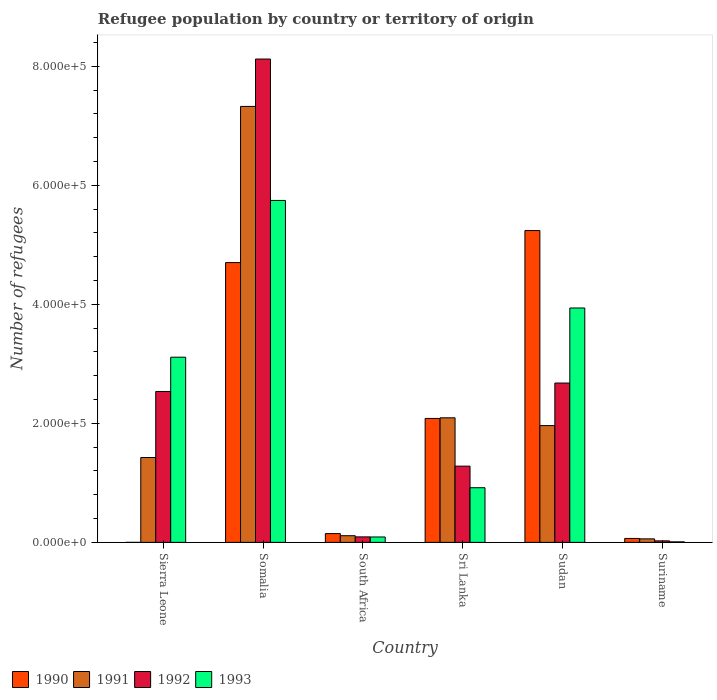How many different coloured bars are there?
Offer a very short reply. 4. How many bars are there on the 1st tick from the left?
Offer a very short reply. 4. How many bars are there on the 5th tick from the right?
Your answer should be compact. 4. What is the label of the 3rd group of bars from the left?
Make the answer very short. South Africa. In how many cases, is the number of bars for a given country not equal to the number of legend labels?
Give a very brief answer. 0. What is the number of refugees in 1990 in South Africa?
Your response must be concise. 1.48e+04. Across all countries, what is the maximum number of refugees in 1992?
Offer a very short reply. 8.12e+05. Across all countries, what is the minimum number of refugees in 1991?
Offer a terse response. 5921. In which country was the number of refugees in 1991 maximum?
Make the answer very short. Somalia. In which country was the number of refugees in 1993 minimum?
Ensure brevity in your answer.  Suriname. What is the total number of refugees in 1992 in the graph?
Your answer should be very brief. 1.47e+06. What is the difference between the number of refugees in 1990 in South Africa and that in Suriname?
Give a very brief answer. 8163. What is the difference between the number of refugees in 1990 in South Africa and the number of refugees in 1991 in Sri Lanka?
Your answer should be compact. -1.95e+05. What is the average number of refugees in 1992 per country?
Offer a terse response. 2.46e+05. What is the difference between the number of refugees of/in 1993 and number of refugees of/in 1992 in South Africa?
Offer a terse response. -147. In how many countries, is the number of refugees in 1991 greater than 400000?
Offer a very short reply. 1. What is the ratio of the number of refugees in 1993 in Sri Lanka to that in Suriname?
Provide a short and direct response. 102.85. What is the difference between the highest and the second highest number of refugees in 1993?
Your answer should be very brief. -2.63e+05. What is the difference between the highest and the lowest number of refugees in 1991?
Offer a terse response. 7.27e+05. Is the sum of the number of refugees in 1993 in Sierra Leone and Sri Lanka greater than the maximum number of refugees in 1990 across all countries?
Offer a very short reply. No. Is it the case that in every country, the sum of the number of refugees in 1991 and number of refugees in 1990 is greater than the sum of number of refugees in 1993 and number of refugees in 1992?
Ensure brevity in your answer.  No. What does the 4th bar from the right in Somalia represents?
Offer a terse response. 1990. Is it the case that in every country, the sum of the number of refugees in 1992 and number of refugees in 1993 is greater than the number of refugees in 1990?
Give a very brief answer. No. How many countries are there in the graph?
Your answer should be compact. 6. What is the difference between two consecutive major ticks on the Y-axis?
Provide a succinct answer. 2.00e+05. Does the graph contain any zero values?
Your answer should be very brief. No. How many legend labels are there?
Make the answer very short. 4. How are the legend labels stacked?
Offer a very short reply. Horizontal. What is the title of the graph?
Your answer should be compact. Refugee population by country or territory of origin. Does "1994" appear as one of the legend labels in the graph?
Make the answer very short. No. What is the label or title of the Y-axis?
Your answer should be very brief. Number of refugees. What is the Number of refugees in 1990 in Sierra Leone?
Offer a terse response. 9. What is the Number of refugees in 1991 in Sierra Leone?
Provide a succinct answer. 1.43e+05. What is the Number of refugees in 1992 in Sierra Leone?
Your answer should be compact. 2.54e+05. What is the Number of refugees in 1993 in Sierra Leone?
Your answer should be very brief. 3.11e+05. What is the Number of refugees in 1990 in Somalia?
Provide a succinct answer. 4.70e+05. What is the Number of refugees of 1991 in Somalia?
Ensure brevity in your answer.  7.33e+05. What is the Number of refugees of 1992 in Somalia?
Provide a succinct answer. 8.12e+05. What is the Number of refugees of 1993 in Somalia?
Your answer should be very brief. 5.75e+05. What is the Number of refugees of 1990 in South Africa?
Your answer should be compact. 1.48e+04. What is the Number of refugees of 1991 in South Africa?
Provide a short and direct response. 1.12e+04. What is the Number of refugees in 1992 in South Africa?
Keep it short and to the point. 9241. What is the Number of refugees of 1993 in South Africa?
Make the answer very short. 9094. What is the Number of refugees of 1990 in Sri Lanka?
Offer a very short reply. 2.08e+05. What is the Number of refugees in 1991 in Sri Lanka?
Your answer should be compact. 2.09e+05. What is the Number of refugees of 1992 in Sri Lanka?
Provide a short and direct response. 1.28e+05. What is the Number of refugees of 1993 in Sri Lanka?
Ensure brevity in your answer.  9.18e+04. What is the Number of refugees of 1990 in Sudan?
Ensure brevity in your answer.  5.24e+05. What is the Number of refugees of 1991 in Sudan?
Provide a succinct answer. 1.96e+05. What is the Number of refugees in 1992 in Sudan?
Ensure brevity in your answer.  2.68e+05. What is the Number of refugees of 1993 in Sudan?
Offer a very short reply. 3.94e+05. What is the Number of refugees of 1990 in Suriname?
Ensure brevity in your answer.  6620. What is the Number of refugees in 1991 in Suriname?
Offer a very short reply. 5921. What is the Number of refugees of 1992 in Suriname?
Make the answer very short. 2545. What is the Number of refugees in 1993 in Suriname?
Your answer should be very brief. 893. Across all countries, what is the maximum Number of refugees in 1990?
Give a very brief answer. 5.24e+05. Across all countries, what is the maximum Number of refugees in 1991?
Keep it short and to the point. 7.33e+05. Across all countries, what is the maximum Number of refugees in 1992?
Ensure brevity in your answer.  8.12e+05. Across all countries, what is the maximum Number of refugees in 1993?
Ensure brevity in your answer.  5.75e+05. Across all countries, what is the minimum Number of refugees in 1991?
Your response must be concise. 5921. Across all countries, what is the minimum Number of refugees of 1992?
Offer a very short reply. 2545. Across all countries, what is the minimum Number of refugees of 1993?
Make the answer very short. 893. What is the total Number of refugees in 1990 in the graph?
Give a very brief answer. 1.22e+06. What is the total Number of refugees of 1991 in the graph?
Offer a very short reply. 1.30e+06. What is the total Number of refugees of 1992 in the graph?
Provide a short and direct response. 1.47e+06. What is the total Number of refugees of 1993 in the graph?
Your response must be concise. 1.38e+06. What is the difference between the Number of refugees of 1990 in Sierra Leone and that in Somalia?
Provide a short and direct response. -4.70e+05. What is the difference between the Number of refugees in 1991 in Sierra Leone and that in Somalia?
Offer a terse response. -5.90e+05. What is the difference between the Number of refugees of 1992 in Sierra Leone and that in Somalia?
Make the answer very short. -5.59e+05. What is the difference between the Number of refugees in 1993 in Sierra Leone and that in Somalia?
Offer a terse response. -2.63e+05. What is the difference between the Number of refugees in 1990 in Sierra Leone and that in South Africa?
Keep it short and to the point. -1.48e+04. What is the difference between the Number of refugees in 1991 in Sierra Leone and that in South Africa?
Your answer should be compact. 1.31e+05. What is the difference between the Number of refugees in 1992 in Sierra Leone and that in South Africa?
Make the answer very short. 2.44e+05. What is the difference between the Number of refugees in 1993 in Sierra Leone and that in South Africa?
Your response must be concise. 3.02e+05. What is the difference between the Number of refugees in 1990 in Sierra Leone and that in Sri Lanka?
Make the answer very short. -2.08e+05. What is the difference between the Number of refugees in 1991 in Sierra Leone and that in Sri Lanka?
Your answer should be compact. -6.67e+04. What is the difference between the Number of refugees of 1992 in Sierra Leone and that in Sri Lanka?
Your answer should be compact. 1.25e+05. What is the difference between the Number of refugees of 1993 in Sierra Leone and that in Sri Lanka?
Your answer should be very brief. 2.19e+05. What is the difference between the Number of refugees in 1990 in Sierra Leone and that in Sudan?
Your response must be concise. -5.24e+05. What is the difference between the Number of refugees of 1991 in Sierra Leone and that in Sudan?
Provide a succinct answer. -5.36e+04. What is the difference between the Number of refugees in 1992 in Sierra Leone and that in Sudan?
Your answer should be very brief. -1.42e+04. What is the difference between the Number of refugees in 1993 in Sierra Leone and that in Sudan?
Keep it short and to the point. -8.27e+04. What is the difference between the Number of refugees of 1990 in Sierra Leone and that in Suriname?
Your answer should be very brief. -6611. What is the difference between the Number of refugees in 1991 in Sierra Leone and that in Suriname?
Your answer should be very brief. 1.37e+05. What is the difference between the Number of refugees in 1992 in Sierra Leone and that in Suriname?
Your response must be concise. 2.51e+05. What is the difference between the Number of refugees of 1993 in Sierra Leone and that in Suriname?
Offer a very short reply. 3.10e+05. What is the difference between the Number of refugees of 1990 in Somalia and that in South Africa?
Provide a succinct answer. 4.55e+05. What is the difference between the Number of refugees of 1991 in Somalia and that in South Africa?
Provide a short and direct response. 7.21e+05. What is the difference between the Number of refugees of 1992 in Somalia and that in South Africa?
Your answer should be very brief. 8.03e+05. What is the difference between the Number of refugees of 1993 in Somalia and that in South Africa?
Provide a succinct answer. 5.66e+05. What is the difference between the Number of refugees in 1990 in Somalia and that in Sri Lanka?
Offer a very short reply. 2.62e+05. What is the difference between the Number of refugees of 1991 in Somalia and that in Sri Lanka?
Your answer should be very brief. 5.23e+05. What is the difference between the Number of refugees in 1992 in Somalia and that in Sri Lanka?
Make the answer very short. 6.84e+05. What is the difference between the Number of refugees in 1993 in Somalia and that in Sri Lanka?
Your answer should be very brief. 4.83e+05. What is the difference between the Number of refugees in 1990 in Somalia and that in Sudan?
Offer a terse response. -5.38e+04. What is the difference between the Number of refugees of 1991 in Somalia and that in Sudan?
Your answer should be compact. 5.36e+05. What is the difference between the Number of refugees in 1992 in Somalia and that in Sudan?
Ensure brevity in your answer.  5.44e+05. What is the difference between the Number of refugees in 1993 in Somalia and that in Sudan?
Provide a succinct answer. 1.81e+05. What is the difference between the Number of refugees of 1990 in Somalia and that in Suriname?
Give a very brief answer. 4.64e+05. What is the difference between the Number of refugees of 1991 in Somalia and that in Suriname?
Provide a short and direct response. 7.27e+05. What is the difference between the Number of refugees of 1992 in Somalia and that in Suriname?
Ensure brevity in your answer.  8.10e+05. What is the difference between the Number of refugees in 1993 in Somalia and that in Suriname?
Make the answer very short. 5.74e+05. What is the difference between the Number of refugees in 1990 in South Africa and that in Sri Lanka?
Give a very brief answer. -1.93e+05. What is the difference between the Number of refugees of 1991 in South Africa and that in Sri Lanka?
Give a very brief answer. -1.98e+05. What is the difference between the Number of refugees in 1992 in South Africa and that in Sri Lanka?
Give a very brief answer. -1.19e+05. What is the difference between the Number of refugees in 1993 in South Africa and that in Sri Lanka?
Offer a very short reply. -8.28e+04. What is the difference between the Number of refugees of 1990 in South Africa and that in Sudan?
Your answer should be compact. -5.09e+05. What is the difference between the Number of refugees in 1991 in South Africa and that in Sudan?
Your response must be concise. -1.85e+05. What is the difference between the Number of refugees of 1992 in South Africa and that in Sudan?
Offer a very short reply. -2.59e+05. What is the difference between the Number of refugees of 1993 in South Africa and that in Sudan?
Make the answer very short. -3.85e+05. What is the difference between the Number of refugees in 1990 in South Africa and that in Suriname?
Your response must be concise. 8163. What is the difference between the Number of refugees of 1991 in South Africa and that in Suriname?
Make the answer very short. 5285. What is the difference between the Number of refugees of 1992 in South Africa and that in Suriname?
Keep it short and to the point. 6696. What is the difference between the Number of refugees of 1993 in South Africa and that in Suriname?
Offer a terse response. 8201. What is the difference between the Number of refugees of 1990 in Sri Lanka and that in Sudan?
Offer a terse response. -3.16e+05. What is the difference between the Number of refugees of 1991 in Sri Lanka and that in Sudan?
Your response must be concise. 1.31e+04. What is the difference between the Number of refugees of 1992 in Sri Lanka and that in Sudan?
Provide a short and direct response. -1.40e+05. What is the difference between the Number of refugees of 1993 in Sri Lanka and that in Sudan?
Your response must be concise. -3.02e+05. What is the difference between the Number of refugees in 1990 in Sri Lanka and that in Suriname?
Your response must be concise. 2.02e+05. What is the difference between the Number of refugees in 1991 in Sri Lanka and that in Suriname?
Provide a succinct answer. 2.03e+05. What is the difference between the Number of refugees of 1992 in Sri Lanka and that in Suriname?
Make the answer very short. 1.26e+05. What is the difference between the Number of refugees of 1993 in Sri Lanka and that in Suriname?
Your response must be concise. 9.10e+04. What is the difference between the Number of refugees in 1990 in Sudan and that in Suriname?
Your answer should be very brief. 5.17e+05. What is the difference between the Number of refugees of 1991 in Sudan and that in Suriname?
Provide a short and direct response. 1.90e+05. What is the difference between the Number of refugees of 1992 in Sudan and that in Suriname?
Your response must be concise. 2.65e+05. What is the difference between the Number of refugees of 1993 in Sudan and that in Suriname?
Offer a terse response. 3.93e+05. What is the difference between the Number of refugees in 1990 in Sierra Leone and the Number of refugees in 1991 in Somalia?
Provide a succinct answer. -7.33e+05. What is the difference between the Number of refugees of 1990 in Sierra Leone and the Number of refugees of 1992 in Somalia?
Make the answer very short. -8.12e+05. What is the difference between the Number of refugees in 1990 in Sierra Leone and the Number of refugees in 1993 in Somalia?
Give a very brief answer. -5.75e+05. What is the difference between the Number of refugees of 1991 in Sierra Leone and the Number of refugees of 1992 in Somalia?
Keep it short and to the point. -6.70e+05. What is the difference between the Number of refugees in 1991 in Sierra Leone and the Number of refugees in 1993 in Somalia?
Offer a terse response. -4.32e+05. What is the difference between the Number of refugees in 1992 in Sierra Leone and the Number of refugees in 1993 in Somalia?
Offer a terse response. -3.21e+05. What is the difference between the Number of refugees of 1990 in Sierra Leone and the Number of refugees of 1991 in South Africa?
Ensure brevity in your answer.  -1.12e+04. What is the difference between the Number of refugees of 1990 in Sierra Leone and the Number of refugees of 1992 in South Africa?
Keep it short and to the point. -9232. What is the difference between the Number of refugees of 1990 in Sierra Leone and the Number of refugees of 1993 in South Africa?
Ensure brevity in your answer.  -9085. What is the difference between the Number of refugees of 1991 in Sierra Leone and the Number of refugees of 1992 in South Africa?
Offer a very short reply. 1.33e+05. What is the difference between the Number of refugees of 1991 in Sierra Leone and the Number of refugees of 1993 in South Africa?
Ensure brevity in your answer.  1.34e+05. What is the difference between the Number of refugees of 1992 in Sierra Leone and the Number of refugees of 1993 in South Africa?
Keep it short and to the point. 2.44e+05. What is the difference between the Number of refugees in 1990 in Sierra Leone and the Number of refugees in 1991 in Sri Lanka?
Offer a terse response. -2.09e+05. What is the difference between the Number of refugees of 1990 in Sierra Leone and the Number of refugees of 1992 in Sri Lanka?
Your answer should be very brief. -1.28e+05. What is the difference between the Number of refugees of 1990 in Sierra Leone and the Number of refugees of 1993 in Sri Lanka?
Offer a very short reply. -9.18e+04. What is the difference between the Number of refugees in 1991 in Sierra Leone and the Number of refugees in 1992 in Sri Lanka?
Your response must be concise. 1.45e+04. What is the difference between the Number of refugees in 1991 in Sierra Leone and the Number of refugees in 1993 in Sri Lanka?
Provide a succinct answer. 5.08e+04. What is the difference between the Number of refugees of 1992 in Sierra Leone and the Number of refugees of 1993 in Sri Lanka?
Make the answer very short. 1.62e+05. What is the difference between the Number of refugees of 1990 in Sierra Leone and the Number of refugees of 1991 in Sudan?
Ensure brevity in your answer.  -1.96e+05. What is the difference between the Number of refugees of 1990 in Sierra Leone and the Number of refugees of 1992 in Sudan?
Offer a terse response. -2.68e+05. What is the difference between the Number of refugees of 1990 in Sierra Leone and the Number of refugees of 1993 in Sudan?
Provide a short and direct response. -3.94e+05. What is the difference between the Number of refugees in 1991 in Sierra Leone and the Number of refugees in 1992 in Sudan?
Provide a succinct answer. -1.25e+05. What is the difference between the Number of refugees of 1991 in Sierra Leone and the Number of refugees of 1993 in Sudan?
Provide a short and direct response. -2.51e+05. What is the difference between the Number of refugees of 1992 in Sierra Leone and the Number of refugees of 1993 in Sudan?
Your answer should be compact. -1.40e+05. What is the difference between the Number of refugees of 1990 in Sierra Leone and the Number of refugees of 1991 in Suriname?
Give a very brief answer. -5912. What is the difference between the Number of refugees in 1990 in Sierra Leone and the Number of refugees in 1992 in Suriname?
Provide a succinct answer. -2536. What is the difference between the Number of refugees in 1990 in Sierra Leone and the Number of refugees in 1993 in Suriname?
Make the answer very short. -884. What is the difference between the Number of refugees in 1991 in Sierra Leone and the Number of refugees in 1992 in Suriname?
Provide a short and direct response. 1.40e+05. What is the difference between the Number of refugees of 1991 in Sierra Leone and the Number of refugees of 1993 in Suriname?
Offer a terse response. 1.42e+05. What is the difference between the Number of refugees of 1992 in Sierra Leone and the Number of refugees of 1993 in Suriname?
Offer a very short reply. 2.53e+05. What is the difference between the Number of refugees of 1990 in Somalia and the Number of refugees of 1991 in South Africa?
Provide a short and direct response. 4.59e+05. What is the difference between the Number of refugees in 1990 in Somalia and the Number of refugees in 1992 in South Africa?
Provide a succinct answer. 4.61e+05. What is the difference between the Number of refugees of 1990 in Somalia and the Number of refugees of 1993 in South Africa?
Your answer should be very brief. 4.61e+05. What is the difference between the Number of refugees of 1991 in Somalia and the Number of refugees of 1992 in South Africa?
Your answer should be compact. 7.23e+05. What is the difference between the Number of refugees in 1991 in Somalia and the Number of refugees in 1993 in South Africa?
Give a very brief answer. 7.24e+05. What is the difference between the Number of refugees of 1992 in Somalia and the Number of refugees of 1993 in South Africa?
Your answer should be compact. 8.03e+05. What is the difference between the Number of refugees in 1990 in Somalia and the Number of refugees in 1991 in Sri Lanka?
Provide a short and direct response. 2.61e+05. What is the difference between the Number of refugees of 1990 in Somalia and the Number of refugees of 1992 in Sri Lanka?
Keep it short and to the point. 3.42e+05. What is the difference between the Number of refugees of 1990 in Somalia and the Number of refugees of 1993 in Sri Lanka?
Your response must be concise. 3.78e+05. What is the difference between the Number of refugees of 1991 in Somalia and the Number of refugees of 1992 in Sri Lanka?
Ensure brevity in your answer.  6.04e+05. What is the difference between the Number of refugees of 1991 in Somalia and the Number of refugees of 1993 in Sri Lanka?
Ensure brevity in your answer.  6.41e+05. What is the difference between the Number of refugees in 1992 in Somalia and the Number of refugees in 1993 in Sri Lanka?
Your answer should be very brief. 7.20e+05. What is the difference between the Number of refugees in 1990 in Somalia and the Number of refugees in 1991 in Sudan?
Give a very brief answer. 2.74e+05. What is the difference between the Number of refugees in 1990 in Somalia and the Number of refugees in 1992 in Sudan?
Your answer should be compact. 2.02e+05. What is the difference between the Number of refugees in 1990 in Somalia and the Number of refugees in 1993 in Sudan?
Offer a terse response. 7.63e+04. What is the difference between the Number of refugees of 1991 in Somalia and the Number of refugees of 1992 in Sudan?
Provide a short and direct response. 4.65e+05. What is the difference between the Number of refugees of 1991 in Somalia and the Number of refugees of 1993 in Sudan?
Your answer should be very brief. 3.39e+05. What is the difference between the Number of refugees of 1992 in Somalia and the Number of refugees of 1993 in Sudan?
Your answer should be very brief. 4.18e+05. What is the difference between the Number of refugees in 1990 in Somalia and the Number of refugees in 1991 in Suriname?
Give a very brief answer. 4.64e+05. What is the difference between the Number of refugees of 1990 in Somalia and the Number of refugees of 1992 in Suriname?
Make the answer very short. 4.68e+05. What is the difference between the Number of refugees of 1990 in Somalia and the Number of refugees of 1993 in Suriname?
Give a very brief answer. 4.69e+05. What is the difference between the Number of refugees in 1991 in Somalia and the Number of refugees in 1992 in Suriname?
Your response must be concise. 7.30e+05. What is the difference between the Number of refugees in 1991 in Somalia and the Number of refugees in 1993 in Suriname?
Make the answer very short. 7.32e+05. What is the difference between the Number of refugees in 1992 in Somalia and the Number of refugees in 1993 in Suriname?
Provide a short and direct response. 8.11e+05. What is the difference between the Number of refugees in 1990 in South Africa and the Number of refugees in 1991 in Sri Lanka?
Provide a succinct answer. -1.95e+05. What is the difference between the Number of refugees of 1990 in South Africa and the Number of refugees of 1992 in Sri Lanka?
Your answer should be very brief. -1.13e+05. What is the difference between the Number of refugees in 1990 in South Africa and the Number of refugees in 1993 in Sri Lanka?
Your response must be concise. -7.71e+04. What is the difference between the Number of refugees in 1991 in South Africa and the Number of refugees in 1992 in Sri Lanka?
Your response must be concise. -1.17e+05. What is the difference between the Number of refugees of 1991 in South Africa and the Number of refugees of 1993 in Sri Lanka?
Keep it short and to the point. -8.06e+04. What is the difference between the Number of refugees of 1992 in South Africa and the Number of refugees of 1993 in Sri Lanka?
Provide a short and direct response. -8.26e+04. What is the difference between the Number of refugees of 1990 in South Africa and the Number of refugees of 1991 in Sudan?
Ensure brevity in your answer.  -1.81e+05. What is the difference between the Number of refugees in 1990 in South Africa and the Number of refugees in 1992 in Sudan?
Your answer should be very brief. -2.53e+05. What is the difference between the Number of refugees in 1990 in South Africa and the Number of refugees in 1993 in Sudan?
Provide a succinct answer. -3.79e+05. What is the difference between the Number of refugees of 1991 in South Africa and the Number of refugees of 1992 in Sudan?
Make the answer very short. -2.57e+05. What is the difference between the Number of refugees in 1991 in South Africa and the Number of refugees in 1993 in Sudan?
Make the answer very short. -3.83e+05. What is the difference between the Number of refugees of 1992 in South Africa and the Number of refugees of 1993 in Sudan?
Your response must be concise. -3.85e+05. What is the difference between the Number of refugees of 1990 in South Africa and the Number of refugees of 1991 in Suriname?
Provide a succinct answer. 8862. What is the difference between the Number of refugees of 1990 in South Africa and the Number of refugees of 1992 in Suriname?
Provide a succinct answer. 1.22e+04. What is the difference between the Number of refugees of 1990 in South Africa and the Number of refugees of 1993 in Suriname?
Offer a very short reply. 1.39e+04. What is the difference between the Number of refugees of 1991 in South Africa and the Number of refugees of 1992 in Suriname?
Offer a very short reply. 8661. What is the difference between the Number of refugees of 1991 in South Africa and the Number of refugees of 1993 in Suriname?
Make the answer very short. 1.03e+04. What is the difference between the Number of refugees in 1992 in South Africa and the Number of refugees in 1993 in Suriname?
Make the answer very short. 8348. What is the difference between the Number of refugees in 1990 in Sri Lanka and the Number of refugees in 1991 in Sudan?
Offer a terse response. 1.20e+04. What is the difference between the Number of refugees in 1990 in Sri Lanka and the Number of refugees in 1992 in Sudan?
Offer a very short reply. -5.95e+04. What is the difference between the Number of refugees of 1990 in Sri Lanka and the Number of refugees of 1993 in Sudan?
Your response must be concise. -1.86e+05. What is the difference between the Number of refugees in 1991 in Sri Lanka and the Number of refugees in 1992 in Sudan?
Make the answer very short. -5.84e+04. What is the difference between the Number of refugees in 1991 in Sri Lanka and the Number of refugees in 1993 in Sudan?
Make the answer very short. -1.85e+05. What is the difference between the Number of refugees in 1992 in Sri Lanka and the Number of refugees in 1993 in Sudan?
Provide a succinct answer. -2.66e+05. What is the difference between the Number of refugees in 1990 in Sri Lanka and the Number of refugees in 1991 in Suriname?
Offer a terse response. 2.02e+05. What is the difference between the Number of refugees of 1990 in Sri Lanka and the Number of refugees of 1992 in Suriname?
Offer a very short reply. 2.06e+05. What is the difference between the Number of refugees of 1990 in Sri Lanka and the Number of refugees of 1993 in Suriname?
Keep it short and to the point. 2.07e+05. What is the difference between the Number of refugees of 1991 in Sri Lanka and the Number of refugees of 1992 in Suriname?
Make the answer very short. 2.07e+05. What is the difference between the Number of refugees of 1991 in Sri Lanka and the Number of refugees of 1993 in Suriname?
Give a very brief answer. 2.08e+05. What is the difference between the Number of refugees in 1992 in Sri Lanka and the Number of refugees in 1993 in Suriname?
Provide a succinct answer. 1.27e+05. What is the difference between the Number of refugees in 1990 in Sudan and the Number of refugees in 1991 in Suriname?
Your answer should be compact. 5.18e+05. What is the difference between the Number of refugees in 1990 in Sudan and the Number of refugees in 1992 in Suriname?
Give a very brief answer. 5.21e+05. What is the difference between the Number of refugees in 1990 in Sudan and the Number of refugees in 1993 in Suriname?
Your response must be concise. 5.23e+05. What is the difference between the Number of refugees in 1991 in Sudan and the Number of refugees in 1992 in Suriname?
Ensure brevity in your answer.  1.94e+05. What is the difference between the Number of refugees in 1991 in Sudan and the Number of refugees in 1993 in Suriname?
Your response must be concise. 1.95e+05. What is the difference between the Number of refugees of 1992 in Sudan and the Number of refugees of 1993 in Suriname?
Provide a short and direct response. 2.67e+05. What is the average Number of refugees in 1990 per country?
Keep it short and to the point. 2.04e+05. What is the average Number of refugees in 1991 per country?
Offer a terse response. 2.16e+05. What is the average Number of refugees in 1992 per country?
Provide a succinct answer. 2.46e+05. What is the average Number of refugees in 1993 per country?
Provide a short and direct response. 2.30e+05. What is the difference between the Number of refugees of 1990 and Number of refugees of 1991 in Sierra Leone?
Your answer should be very brief. -1.43e+05. What is the difference between the Number of refugees in 1990 and Number of refugees in 1992 in Sierra Leone?
Your response must be concise. -2.54e+05. What is the difference between the Number of refugees in 1990 and Number of refugees in 1993 in Sierra Leone?
Your response must be concise. -3.11e+05. What is the difference between the Number of refugees of 1991 and Number of refugees of 1992 in Sierra Leone?
Offer a very short reply. -1.11e+05. What is the difference between the Number of refugees of 1991 and Number of refugees of 1993 in Sierra Leone?
Provide a succinct answer. -1.69e+05. What is the difference between the Number of refugees in 1992 and Number of refugees in 1993 in Sierra Leone?
Give a very brief answer. -5.76e+04. What is the difference between the Number of refugees of 1990 and Number of refugees of 1991 in Somalia?
Keep it short and to the point. -2.62e+05. What is the difference between the Number of refugees in 1990 and Number of refugees in 1992 in Somalia?
Your answer should be very brief. -3.42e+05. What is the difference between the Number of refugees in 1990 and Number of refugees in 1993 in Somalia?
Your answer should be compact. -1.04e+05. What is the difference between the Number of refugees in 1991 and Number of refugees in 1992 in Somalia?
Your answer should be very brief. -7.96e+04. What is the difference between the Number of refugees in 1991 and Number of refugees in 1993 in Somalia?
Keep it short and to the point. 1.58e+05. What is the difference between the Number of refugees of 1992 and Number of refugees of 1993 in Somalia?
Provide a short and direct response. 2.38e+05. What is the difference between the Number of refugees of 1990 and Number of refugees of 1991 in South Africa?
Your answer should be very brief. 3577. What is the difference between the Number of refugees in 1990 and Number of refugees in 1992 in South Africa?
Provide a succinct answer. 5542. What is the difference between the Number of refugees of 1990 and Number of refugees of 1993 in South Africa?
Ensure brevity in your answer.  5689. What is the difference between the Number of refugees of 1991 and Number of refugees of 1992 in South Africa?
Your answer should be compact. 1965. What is the difference between the Number of refugees in 1991 and Number of refugees in 1993 in South Africa?
Your answer should be compact. 2112. What is the difference between the Number of refugees of 1992 and Number of refugees of 1993 in South Africa?
Give a very brief answer. 147. What is the difference between the Number of refugees of 1990 and Number of refugees of 1991 in Sri Lanka?
Your answer should be compact. -1078. What is the difference between the Number of refugees in 1990 and Number of refugees in 1992 in Sri Lanka?
Your response must be concise. 8.02e+04. What is the difference between the Number of refugees of 1990 and Number of refugees of 1993 in Sri Lanka?
Offer a terse response. 1.16e+05. What is the difference between the Number of refugees of 1991 and Number of refugees of 1992 in Sri Lanka?
Give a very brief answer. 8.12e+04. What is the difference between the Number of refugees of 1991 and Number of refugees of 1993 in Sri Lanka?
Offer a very short reply. 1.18e+05. What is the difference between the Number of refugees in 1992 and Number of refugees in 1993 in Sri Lanka?
Provide a succinct answer. 3.63e+04. What is the difference between the Number of refugees in 1990 and Number of refugees in 1991 in Sudan?
Give a very brief answer. 3.28e+05. What is the difference between the Number of refugees of 1990 and Number of refugees of 1992 in Sudan?
Make the answer very short. 2.56e+05. What is the difference between the Number of refugees of 1990 and Number of refugees of 1993 in Sudan?
Make the answer very short. 1.30e+05. What is the difference between the Number of refugees in 1991 and Number of refugees in 1992 in Sudan?
Your answer should be compact. -7.15e+04. What is the difference between the Number of refugees of 1991 and Number of refugees of 1993 in Sudan?
Offer a terse response. -1.98e+05. What is the difference between the Number of refugees in 1992 and Number of refugees in 1993 in Sudan?
Your answer should be very brief. -1.26e+05. What is the difference between the Number of refugees in 1990 and Number of refugees in 1991 in Suriname?
Give a very brief answer. 699. What is the difference between the Number of refugees in 1990 and Number of refugees in 1992 in Suriname?
Your answer should be very brief. 4075. What is the difference between the Number of refugees in 1990 and Number of refugees in 1993 in Suriname?
Offer a very short reply. 5727. What is the difference between the Number of refugees in 1991 and Number of refugees in 1992 in Suriname?
Your answer should be very brief. 3376. What is the difference between the Number of refugees in 1991 and Number of refugees in 1993 in Suriname?
Ensure brevity in your answer.  5028. What is the difference between the Number of refugees of 1992 and Number of refugees of 1993 in Suriname?
Make the answer very short. 1652. What is the ratio of the Number of refugees of 1991 in Sierra Leone to that in Somalia?
Your response must be concise. 0.19. What is the ratio of the Number of refugees in 1992 in Sierra Leone to that in Somalia?
Your answer should be very brief. 0.31. What is the ratio of the Number of refugees of 1993 in Sierra Leone to that in Somalia?
Offer a terse response. 0.54. What is the ratio of the Number of refugees in 1990 in Sierra Leone to that in South Africa?
Your response must be concise. 0. What is the ratio of the Number of refugees of 1991 in Sierra Leone to that in South Africa?
Offer a terse response. 12.73. What is the ratio of the Number of refugees of 1992 in Sierra Leone to that in South Africa?
Make the answer very short. 27.44. What is the ratio of the Number of refugees of 1993 in Sierra Leone to that in South Africa?
Provide a succinct answer. 34.22. What is the ratio of the Number of refugees in 1991 in Sierra Leone to that in Sri Lanka?
Offer a very short reply. 0.68. What is the ratio of the Number of refugees of 1992 in Sierra Leone to that in Sri Lanka?
Give a very brief answer. 1.98. What is the ratio of the Number of refugees of 1993 in Sierra Leone to that in Sri Lanka?
Make the answer very short. 3.39. What is the ratio of the Number of refugees of 1990 in Sierra Leone to that in Sudan?
Your answer should be compact. 0. What is the ratio of the Number of refugees in 1991 in Sierra Leone to that in Sudan?
Ensure brevity in your answer.  0.73. What is the ratio of the Number of refugees of 1992 in Sierra Leone to that in Sudan?
Offer a terse response. 0.95. What is the ratio of the Number of refugees in 1993 in Sierra Leone to that in Sudan?
Offer a terse response. 0.79. What is the ratio of the Number of refugees of 1990 in Sierra Leone to that in Suriname?
Make the answer very short. 0. What is the ratio of the Number of refugees in 1991 in Sierra Leone to that in Suriname?
Your response must be concise. 24.09. What is the ratio of the Number of refugees of 1992 in Sierra Leone to that in Suriname?
Ensure brevity in your answer.  99.64. What is the ratio of the Number of refugees in 1993 in Sierra Leone to that in Suriname?
Ensure brevity in your answer.  348.47. What is the ratio of the Number of refugees of 1990 in Somalia to that in South Africa?
Provide a succinct answer. 31.8. What is the ratio of the Number of refugees of 1991 in Somalia to that in South Africa?
Give a very brief answer. 65.38. What is the ratio of the Number of refugees in 1992 in Somalia to that in South Africa?
Your answer should be very brief. 87.89. What is the ratio of the Number of refugees in 1993 in Somalia to that in South Africa?
Give a very brief answer. 63.19. What is the ratio of the Number of refugees in 1990 in Somalia to that in Sri Lanka?
Offer a very short reply. 2.26. What is the ratio of the Number of refugees of 1991 in Somalia to that in Sri Lanka?
Give a very brief answer. 3.5. What is the ratio of the Number of refugees of 1992 in Somalia to that in Sri Lanka?
Your response must be concise. 6.34. What is the ratio of the Number of refugees of 1993 in Somalia to that in Sri Lanka?
Offer a very short reply. 6.26. What is the ratio of the Number of refugees of 1990 in Somalia to that in Sudan?
Make the answer very short. 0.9. What is the ratio of the Number of refugees in 1991 in Somalia to that in Sudan?
Make the answer very short. 3.73. What is the ratio of the Number of refugees in 1992 in Somalia to that in Sudan?
Offer a very short reply. 3.03. What is the ratio of the Number of refugees in 1993 in Somalia to that in Sudan?
Your answer should be very brief. 1.46. What is the ratio of the Number of refugees of 1990 in Somalia to that in Suriname?
Your answer should be very brief. 71.02. What is the ratio of the Number of refugees of 1991 in Somalia to that in Suriname?
Offer a terse response. 123.73. What is the ratio of the Number of refugees in 1992 in Somalia to that in Suriname?
Keep it short and to the point. 319.13. What is the ratio of the Number of refugees in 1993 in Somalia to that in Suriname?
Your answer should be very brief. 643.47. What is the ratio of the Number of refugees in 1990 in South Africa to that in Sri Lanka?
Offer a very short reply. 0.07. What is the ratio of the Number of refugees of 1991 in South Africa to that in Sri Lanka?
Your answer should be compact. 0.05. What is the ratio of the Number of refugees of 1992 in South Africa to that in Sri Lanka?
Make the answer very short. 0.07. What is the ratio of the Number of refugees of 1993 in South Africa to that in Sri Lanka?
Offer a very short reply. 0.1. What is the ratio of the Number of refugees of 1990 in South Africa to that in Sudan?
Offer a terse response. 0.03. What is the ratio of the Number of refugees in 1991 in South Africa to that in Sudan?
Provide a succinct answer. 0.06. What is the ratio of the Number of refugees in 1992 in South Africa to that in Sudan?
Ensure brevity in your answer.  0.03. What is the ratio of the Number of refugees of 1993 in South Africa to that in Sudan?
Make the answer very short. 0.02. What is the ratio of the Number of refugees of 1990 in South Africa to that in Suriname?
Your answer should be very brief. 2.23. What is the ratio of the Number of refugees of 1991 in South Africa to that in Suriname?
Ensure brevity in your answer.  1.89. What is the ratio of the Number of refugees of 1992 in South Africa to that in Suriname?
Ensure brevity in your answer.  3.63. What is the ratio of the Number of refugees of 1993 in South Africa to that in Suriname?
Offer a terse response. 10.18. What is the ratio of the Number of refugees in 1990 in Sri Lanka to that in Sudan?
Your answer should be very brief. 0.4. What is the ratio of the Number of refugees of 1991 in Sri Lanka to that in Sudan?
Your answer should be compact. 1.07. What is the ratio of the Number of refugees of 1992 in Sri Lanka to that in Sudan?
Provide a short and direct response. 0.48. What is the ratio of the Number of refugees in 1993 in Sri Lanka to that in Sudan?
Offer a terse response. 0.23. What is the ratio of the Number of refugees in 1990 in Sri Lanka to that in Suriname?
Your answer should be compact. 31.46. What is the ratio of the Number of refugees of 1991 in Sri Lanka to that in Suriname?
Provide a succinct answer. 35.36. What is the ratio of the Number of refugees of 1992 in Sri Lanka to that in Suriname?
Your response must be concise. 50.34. What is the ratio of the Number of refugees of 1993 in Sri Lanka to that in Suriname?
Give a very brief answer. 102.85. What is the ratio of the Number of refugees in 1990 in Sudan to that in Suriname?
Provide a succinct answer. 79.15. What is the ratio of the Number of refugees of 1991 in Sudan to that in Suriname?
Provide a succinct answer. 33.14. What is the ratio of the Number of refugees in 1992 in Sudan to that in Suriname?
Your answer should be very brief. 105.21. What is the ratio of the Number of refugees in 1993 in Sudan to that in Suriname?
Your answer should be very brief. 441.06. What is the difference between the highest and the second highest Number of refugees in 1990?
Keep it short and to the point. 5.38e+04. What is the difference between the highest and the second highest Number of refugees in 1991?
Ensure brevity in your answer.  5.23e+05. What is the difference between the highest and the second highest Number of refugees of 1992?
Give a very brief answer. 5.44e+05. What is the difference between the highest and the second highest Number of refugees in 1993?
Your answer should be very brief. 1.81e+05. What is the difference between the highest and the lowest Number of refugees of 1990?
Your answer should be compact. 5.24e+05. What is the difference between the highest and the lowest Number of refugees in 1991?
Your answer should be very brief. 7.27e+05. What is the difference between the highest and the lowest Number of refugees of 1992?
Offer a very short reply. 8.10e+05. What is the difference between the highest and the lowest Number of refugees in 1993?
Your response must be concise. 5.74e+05. 